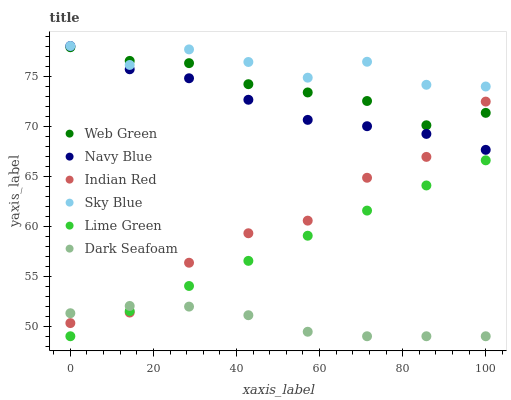Does Dark Seafoam have the minimum area under the curve?
Answer yes or no. Yes. Does Sky Blue have the maximum area under the curve?
Answer yes or no. Yes. Does Web Green have the minimum area under the curve?
Answer yes or no. No. Does Web Green have the maximum area under the curve?
Answer yes or no. No. Is Lime Green the smoothest?
Answer yes or no. Yes. Is Indian Red the roughest?
Answer yes or no. Yes. Is Web Green the smoothest?
Answer yes or no. No. Is Web Green the roughest?
Answer yes or no. No. Does Dark Seafoam have the lowest value?
Answer yes or no. Yes. Does Web Green have the lowest value?
Answer yes or no. No. Does Sky Blue have the highest value?
Answer yes or no. Yes. Does Web Green have the highest value?
Answer yes or no. No. Is Dark Seafoam less than Navy Blue?
Answer yes or no. Yes. Is Navy Blue greater than Dark Seafoam?
Answer yes or no. Yes. Does Navy Blue intersect Web Green?
Answer yes or no. Yes. Is Navy Blue less than Web Green?
Answer yes or no. No. Is Navy Blue greater than Web Green?
Answer yes or no. No. Does Dark Seafoam intersect Navy Blue?
Answer yes or no. No. 